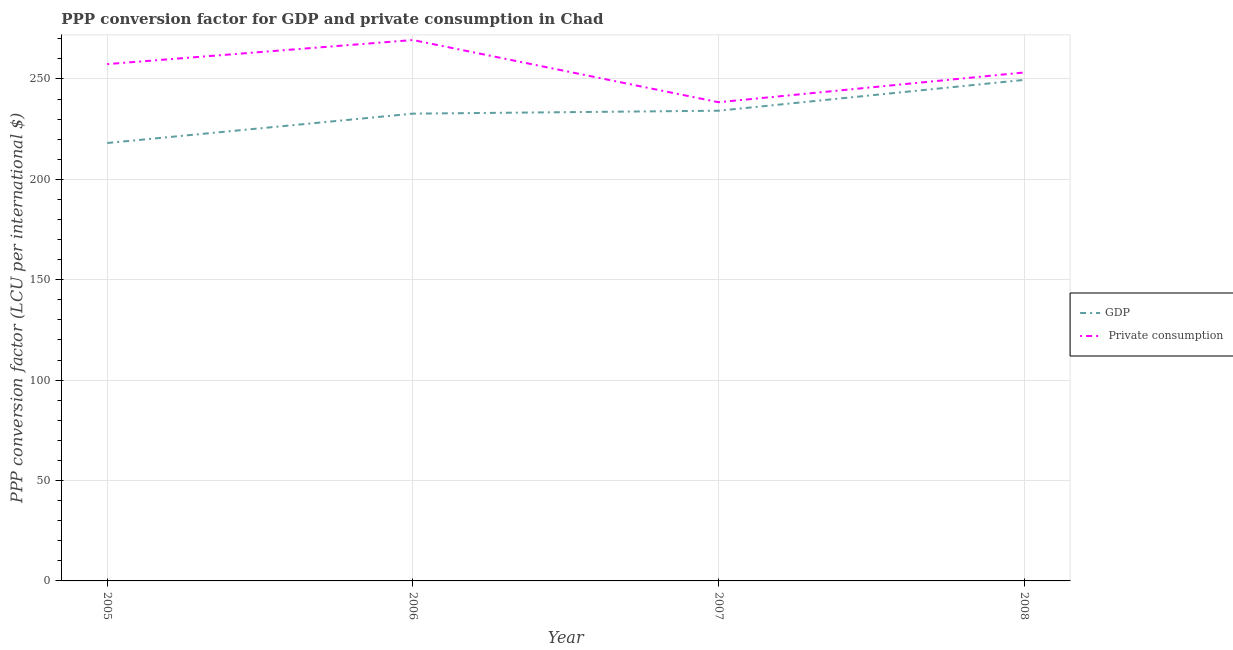Is the number of lines equal to the number of legend labels?
Make the answer very short. Yes. What is the ppp conversion factor for private consumption in 2005?
Your answer should be very brief. 257.38. Across all years, what is the maximum ppp conversion factor for gdp?
Offer a very short reply. 249.53. Across all years, what is the minimum ppp conversion factor for private consumption?
Your answer should be compact. 238.4. In which year was the ppp conversion factor for gdp maximum?
Offer a very short reply. 2008. What is the total ppp conversion factor for private consumption in the graph?
Your response must be concise. 1018.39. What is the difference between the ppp conversion factor for gdp in 2005 and that in 2008?
Give a very brief answer. -31.44. What is the difference between the ppp conversion factor for private consumption in 2006 and the ppp conversion factor for gdp in 2005?
Give a very brief answer. 51.29. What is the average ppp conversion factor for gdp per year?
Your answer should be very brief. 233.63. In the year 2008, what is the difference between the ppp conversion factor for gdp and ppp conversion factor for private consumption?
Offer a terse response. -3.7. What is the ratio of the ppp conversion factor for private consumption in 2005 to that in 2007?
Offer a very short reply. 1.08. What is the difference between the highest and the second highest ppp conversion factor for private consumption?
Offer a very short reply. 11.99. What is the difference between the highest and the lowest ppp conversion factor for private consumption?
Your response must be concise. 30.98. Is the ppp conversion factor for gdp strictly greater than the ppp conversion factor for private consumption over the years?
Keep it short and to the point. No. How many lines are there?
Provide a succinct answer. 2. How many legend labels are there?
Offer a terse response. 2. How are the legend labels stacked?
Offer a terse response. Vertical. What is the title of the graph?
Your answer should be compact. PPP conversion factor for GDP and private consumption in Chad. What is the label or title of the X-axis?
Provide a succinct answer. Year. What is the label or title of the Y-axis?
Offer a terse response. PPP conversion factor (LCU per international $). What is the PPP conversion factor (LCU per international $) of GDP in 2005?
Offer a very short reply. 218.09. What is the PPP conversion factor (LCU per international $) in  Private consumption in 2005?
Your answer should be compact. 257.38. What is the PPP conversion factor (LCU per international $) in GDP in 2006?
Give a very brief answer. 232.72. What is the PPP conversion factor (LCU per international $) in  Private consumption in 2006?
Make the answer very short. 269.38. What is the PPP conversion factor (LCU per international $) of GDP in 2007?
Keep it short and to the point. 234.17. What is the PPP conversion factor (LCU per international $) in  Private consumption in 2007?
Offer a terse response. 238.4. What is the PPP conversion factor (LCU per international $) in GDP in 2008?
Make the answer very short. 249.53. What is the PPP conversion factor (LCU per international $) of  Private consumption in 2008?
Your response must be concise. 253.23. Across all years, what is the maximum PPP conversion factor (LCU per international $) of GDP?
Ensure brevity in your answer.  249.53. Across all years, what is the maximum PPP conversion factor (LCU per international $) in  Private consumption?
Keep it short and to the point. 269.38. Across all years, what is the minimum PPP conversion factor (LCU per international $) of GDP?
Make the answer very short. 218.09. Across all years, what is the minimum PPP conversion factor (LCU per international $) in  Private consumption?
Your answer should be compact. 238.4. What is the total PPP conversion factor (LCU per international $) of GDP in the graph?
Ensure brevity in your answer.  934.51. What is the total PPP conversion factor (LCU per international $) of  Private consumption in the graph?
Provide a short and direct response. 1018.39. What is the difference between the PPP conversion factor (LCU per international $) in GDP in 2005 and that in 2006?
Your response must be concise. -14.63. What is the difference between the PPP conversion factor (LCU per international $) in  Private consumption in 2005 and that in 2006?
Give a very brief answer. -11.99. What is the difference between the PPP conversion factor (LCU per international $) of GDP in 2005 and that in 2007?
Offer a terse response. -16.08. What is the difference between the PPP conversion factor (LCU per international $) in  Private consumption in 2005 and that in 2007?
Offer a very short reply. 18.98. What is the difference between the PPP conversion factor (LCU per international $) in GDP in 2005 and that in 2008?
Your answer should be very brief. -31.44. What is the difference between the PPP conversion factor (LCU per international $) in  Private consumption in 2005 and that in 2008?
Your response must be concise. 4.16. What is the difference between the PPP conversion factor (LCU per international $) in GDP in 2006 and that in 2007?
Offer a terse response. -1.45. What is the difference between the PPP conversion factor (LCU per international $) of  Private consumption in 2006 and that in 2007?
Keep it short and to the point. 30.98. What is the difference between the PPP conversion factor (LCU per international $) of GDP in 2006 and that in 2008?
Offer a terse response. -16.81. What is the difference between the PPP conversion factor (LCU per international $) in  Private consumption in 2006 and that in 2008?
Offer a very short reply. 16.15. What is the difference between the PPP conversion factor (LCU per international $) in GDP in 2007 and that in 2008?
Offer a terse response. -15.36. What is the difference between the PPP conversion factor (LCU per international $) of  Private consumption in 2007 and that in 2008?
Your answer should be compact. -14.83. What is the difference between the PPP conversion factor (LCU per international $) in GDP in 2005 and the PPP conversion factor (LCU per international $) in  Private consumption in 2006?
Keep it short and to the point. -51.29. What is the difference between the PPP conversion factor (LCU per international $) in GDP in 2005 and the PPP conversion factor (LCU per international $) in  Private consumption in 2007?
Your answer should be compact. -20.31. What is the difference between the PPP conversion factor (LCU per international $) in GDP in 2005 and the PPP conversion factor (LCU per international $) in  Private consumption in 2008?
Make the answer very short. -35.13. What is the difference between the PPP conversion factor (LCU per international $) in GDP in 2006 and the PPP conversion factor (LCU per international $) in  Private consumption in 2007?
Make the answer very short. -5.68. What is the difference between the PPP conversion factor (LCU per international $) in GDP in 2006 and the PPP conversion factor (LCU per international $) in  Private consumption in 2008?
Your response must be concise. -20.51. What is the difference between the PPP conversion factor (LCU per international $) in GDP in 2007 and the PPP conversion factor (LCU per international $) in  Private consumption in 2008?
Your response must be concise. -19.06. What is the average PPP conversion factor (LCU per international $) of GDP per year?
Ensure brevity in your answer.  233.63. What is the average PPP conversion factor (LCU per international $) in  Private consumption per year?
Your answer should be compact. 254.6. In the year 2005, what is the difference between the PPP conversion factor (LCU per international $) of GDP and PPP conversion factor (LCU per international $) of  Private consumption?
Your answer should be compact. -39.29. In the year 2006, what is the difference between the PPP conversion factor (LCU per international $) of GDP and PPP conversion factor (LCU per international $) of  Private consumption?
Keep it short and to the point. -36.66. In the year 2007, what is the difference between the PPP conversion factor (LCU per international $) in GDP and PPP conversion factor (LCU per international $) in  Private consumption?
Provide a succinct answer. -4.23. In the year 2008, what is the difference between the PPP conversion factor (LCU per international $) of GDP and PPP conversion factor (LCU per international $) of  Private consumption?
Provide a succinct answer. -3.7. What is the ratio of the PPP conversion factor (LCU per international $) of GDP in 2005 to that in 2006?
Your answer should be compact. 0.94. What is the ratio of the PPP conversion factor (LCU per international $) of  Private consumption in 2005 to that in 2006?
Provide a short and direct response. 0.96. What is the ratio of the PPP conversion factor (LCU per international $) in GDP in 2005 to that in 2007?
Offer a very short reply. 0.93. What is the ratio of the PPP conversion factor (LCU per international $) of  Private consumption in 2005 to that in 2007?
Your answer should be compact. 1.08. What is the ratio of the PPP conversion factor (LCU per international $) in GDP in 2005 to that in 2008?
Your answer should be very brief. 0.87. What is the ratio of the PPP conversion factor (LCU per international $) of  Private consumption in 2005 to that in 2008?
Provide a short and direct response. 1.02. What is the ratio of the PPP conversion factor (LCU per international $) of  Private consumption in 2006 to that in 2007?
Your response must be concise. 1.13. What is the ratio of the PPP conversion factor (LCU per international $) of GDP in 2006 to that in 2008?
Your response must be concise. 0.93. What is the ratio of the PPP conversion factor (LCU per international $) in  Private consumption in 2006 to that in 2008?
Ensure brevity in your answer.  1.06. What is the ratio of the PPP conversion factor (LCU per international $) of GDP in 2007 to that in 2008?
Keep it short and to the point. 0.94. What is the ratio of the PPP conversion factor (LCU per international $) of  Private consumption in 2007 to that in 2008?
Ensure brevity in your answer.  0.94. What is the difference between the highest and the second highest PPP conversion factor (LCU per international $) of GDP?
Give a very brief answer. 15.36. What is the difference between the highest and the second highest PPP conversion factor (LCU per international $) in  Private consumption?
Provide a succinct answer. 11.99. What is the difference between the highest and the lowest PPP conversion factor (LCU per international $) of GDP?
Provide a succinct answer. 31.44. What is the difference between the highest and the lowest PPP conversion factor (LCU per international $) of  Private consumption?
Give a very brief answer. 30.98. 